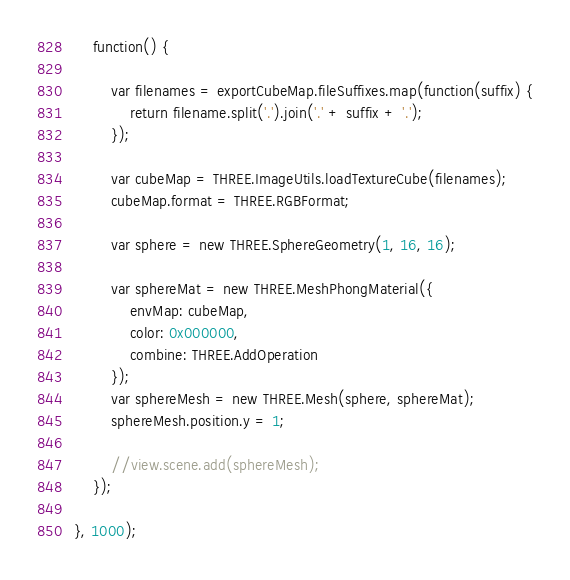<code> <loc_0><loc_0><loc_500><loc_500><_JavaScript_>	function() {

		var filenames = exportCubeMap.fileSuffixes.map(function(suffix) {
			return filename.split('.').join('.' + suffix + '.');
		});

		var cubeMap = THREE.ImageUtils.loadTextureCube(filenames);
		cubeMap.format = THREE.RGBFormat;

		var sphere = new THREE.SphereGeometry(1, 16, 16);

		var sphereMat = new THREE.MeshPhongMaterial({
			envMap: cubeMap, 
			color: 0x000000,
			combine: THREE.AddOperation
		});
		var sphereMesh = new THREE.Mesh(sphere, sphereMat);
		sphereMesh.position.y = 1;

		//view.scene.add(sphereMesh);
	});

}, 1000);</code> 